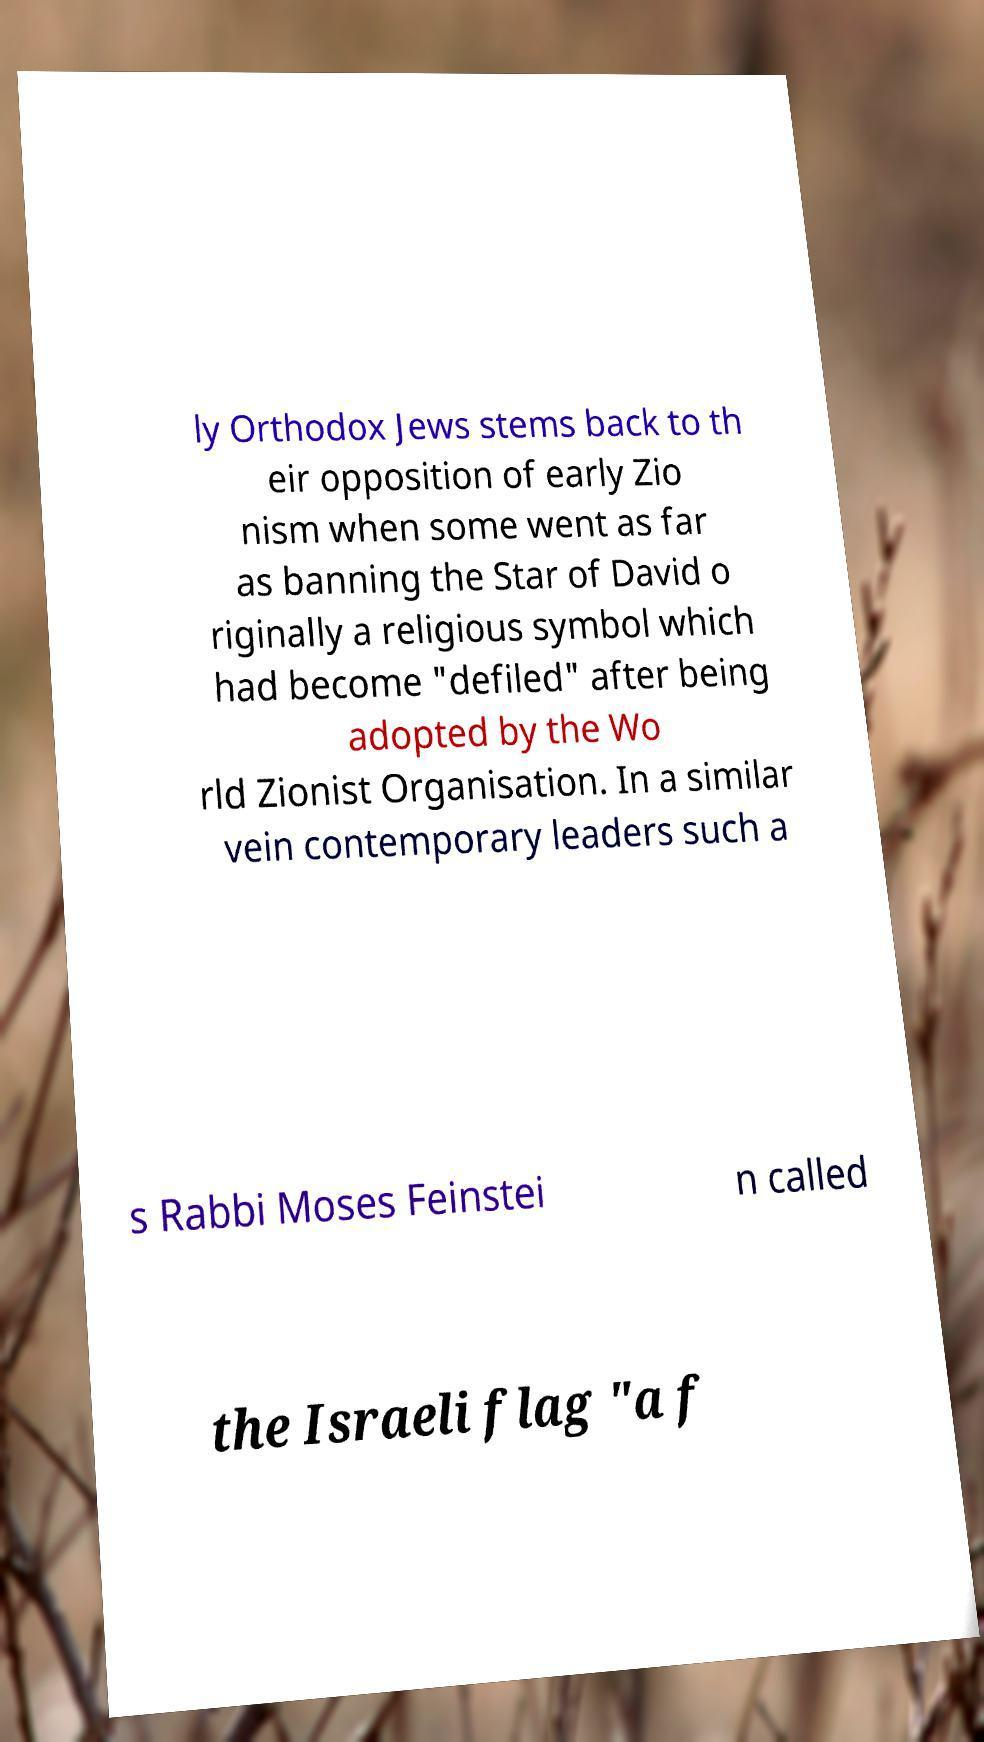I need the written content from this picture converted into text. Can you do that? ly Orthodox Jews stems back to th eir opposition of early Zio nism when some went as far as banning the Star of David o riginally a religious symbol which had become "defiled" after being adopted by the Wo rld Zionist Organisation. In a similar vein contemporary leaders such a s Rabbi Moses Feinstei n called the Israeli flag "a f 